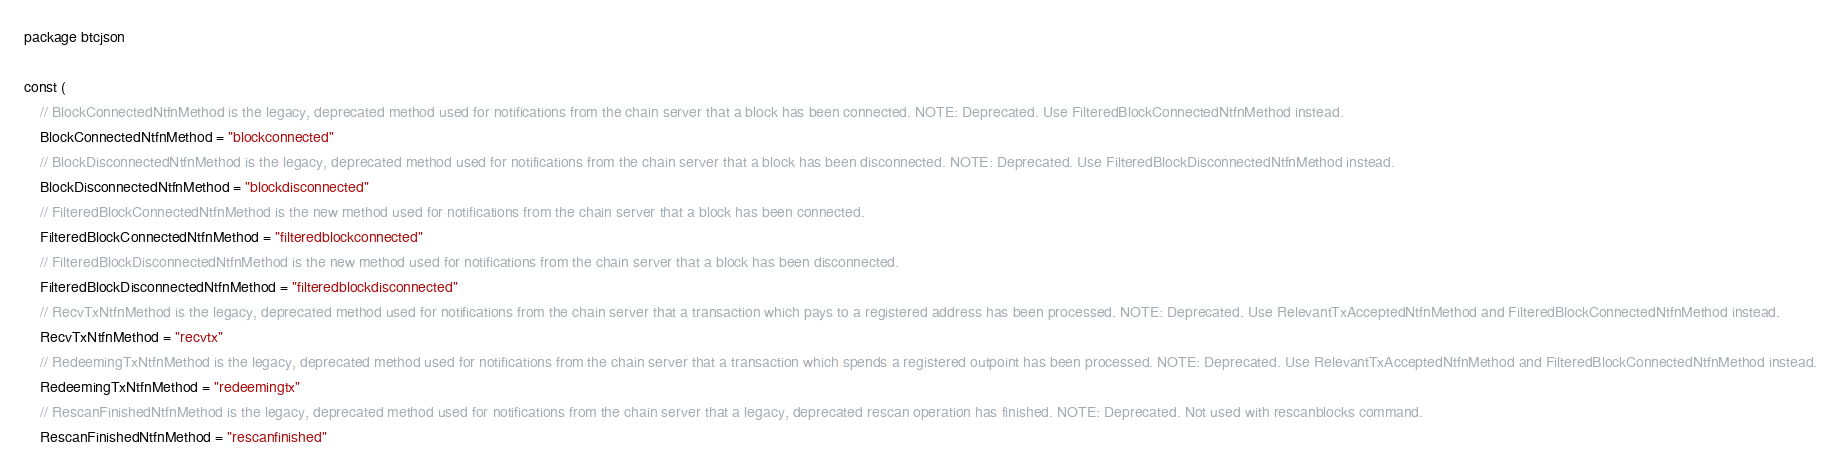Convert code to text. <code><loc_0><loc_0><loc_500><loc_500><_Go_>package btcjson

const (
	// BlockConnectedNtfnMethod is the legacy, deprecated method used for notifications from the chain server that a block has been connected. NOTE: Deprecated. Use FilteredBlockConnectedNtfnMethod instead.
	BlockConnectedNtfnMethod = "blockconnected"
	// BlockDisconnectedNtfnMethod is the legacy, deprecated method used for notifications from the chain server that a block has been disconnected. NOTE: Deprecated. Use FilteredBlockDisconnectedNtfnMethod instead.
	BlockDisconnectedNtfnMethod = "blockdisconnected"
	// FilteredBlockConnectedNtfnMethod is the new method used for notifications from the chain server that a block has been connected.
	FilteredBlockConnectedNtfnMethod = "filteredblockconnected"
	// FilteredBlockDisconnectedNtfnMethod is the new method used for notifications from the chain server that a block has been disconnected.
	FilteredBlockDisconnectedNtfnMethod = "filteredblockdisconnected"
	// RecvTxNtfnMethod is the legacy, deprecated method used for notifications from the chain server that a transaction which pays to a registered address has been processed. NOTE: Deprecated. Use RelevantTxAcceptedNtfnMethod and FilteredBlockConnectedNtfnMethod instead.
	RecvTxNtfnMethod = "recvtx"
	// RedeemingTxNtfnMethod is the legacy, deprecated method used for notifications from the chain server that a transaction which spends a registered outpoint has been processed. NOTE: Deprecated. Use RelevantTxAcceptedNtfnMethod and FilteredBlockConnectedNtfnMethod instead.
	RedeemingTxNtfnMethod = "redeemingtx"
	// RescanFinishedNtfnMethod is the legacy, deprecated method used for notifications from the chain server that a legacy, deprecated rescan operation has finished. NOTE: Deprecated. Not used with rescanblocks command.
	RescanFinishedNtfnMethod = "rescanfinished"</code> 